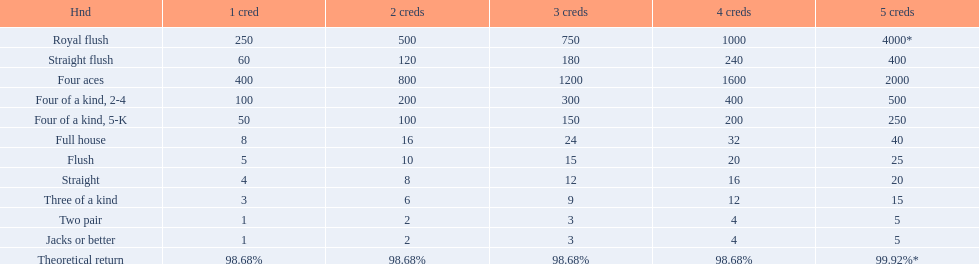What are the hands in super aces? Royal flush, Straight flush, Four aces, Four of a kind, 2-4, Four of a kind, 5-K, Full house, Flush, Straight, Three of a kind, Two pair, Jacks or better. What hand gives the highest credits? Royal flush. 